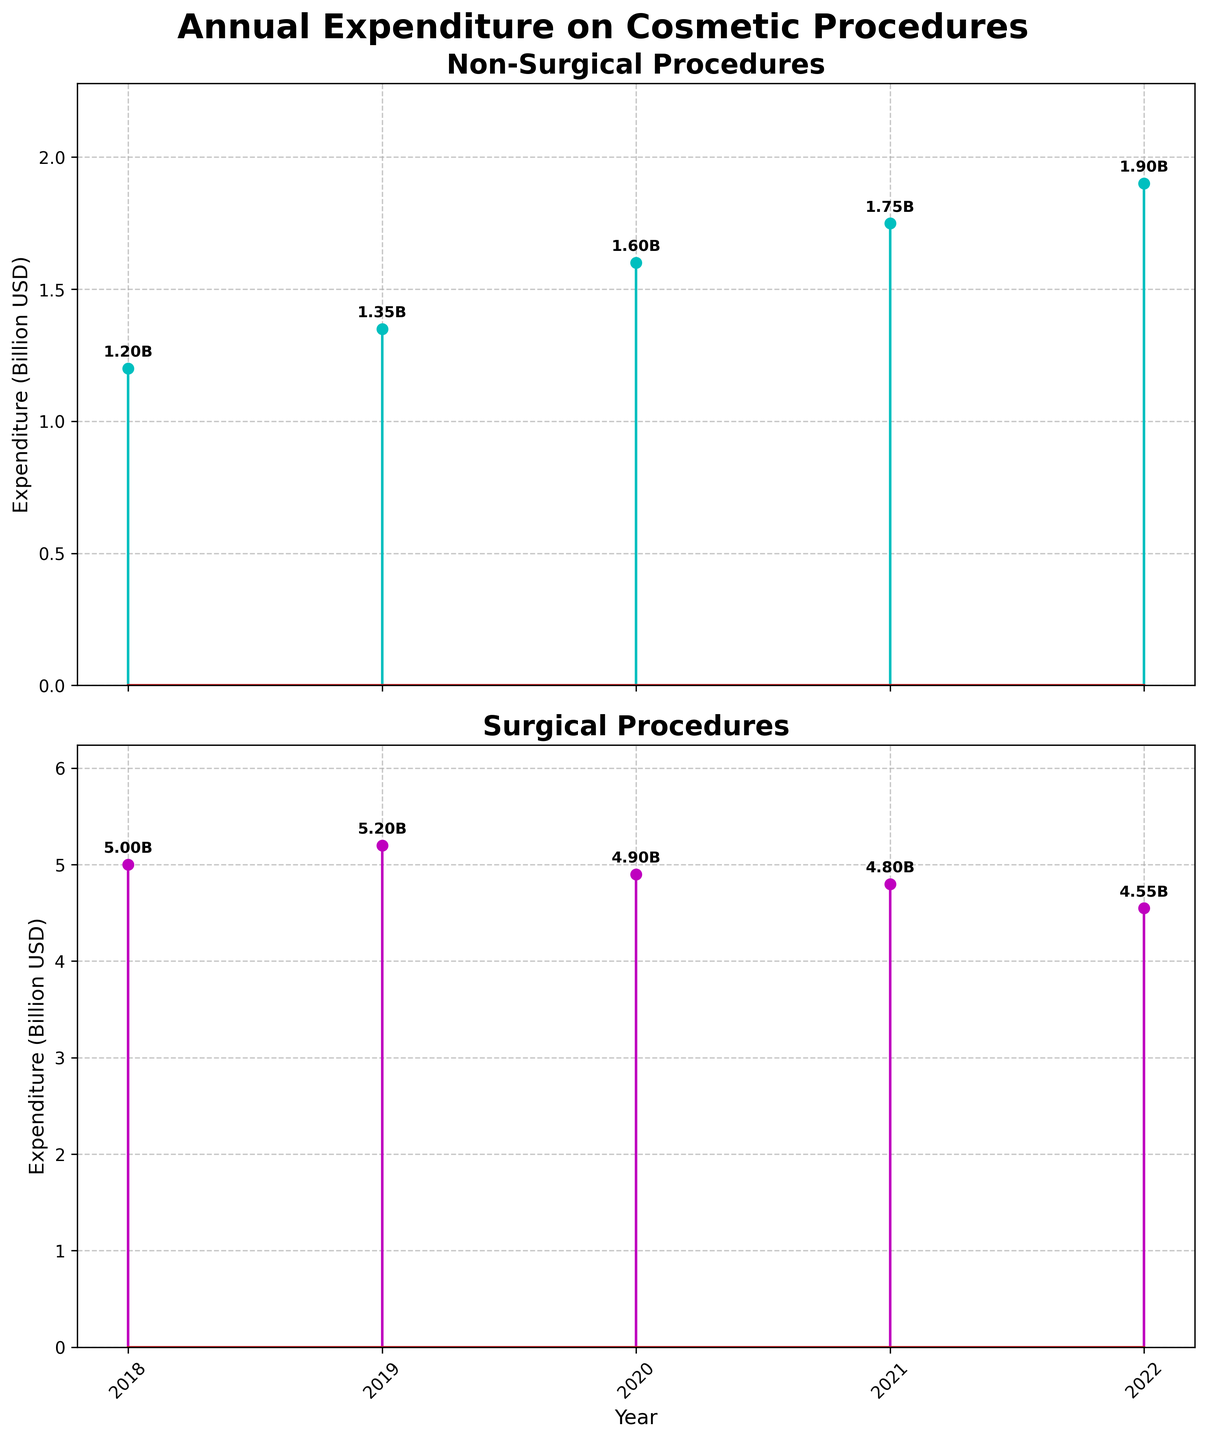What are the titles of the subplots? The titles are located above each subplot. The first subplot is titled "Non-Surgical Procedures" and the second subplot is titled "Surgical Procedures".
Answer: Non-Surgical Procedures, Surgical Procedures What is the total expenditure on Non-Surgical procedures in 2022? The value is labeled directly above the data point at the year 2022 in the Non-Surgical subplot.
Answer: $1.90B Which year had the highest expenditure on Surgical procedures? Look at the highest data point in the Surgical subplot and check the corresponding year marked on the x-axis. The highest data point is in the year 2019.
Answer: 2019 How did the expenditure on Non-Surgical procedures change from 2018 to 2022? Identify the values for the years 2018 and 2022 in the Non-Surgical subplot, then subtract the 2018 value from the 2022 value: 1.90 - 1.20 = 0.7. The expenditure increased by $0.70B.
Answer: Increased by $0.70B How does the expenditure on Non-Surgical procedures in 2022 compare to Surgical procedures in the same year? Locate both values for 2022 in the Non-Surgical and Surgical subplots. Non-Surgical is 1.90B, and Surgical is 4.55B. Compare the two: 1.90 is less than 4.55, so the expenditure on Non-Surgical is lower.
Answer: Non-Surgical is lower What is the average annual expenditure on Non-Surgical procedures over the period 2018-2022? Sum all Non-Surgical expenditures and divide by the number of years: (1.20 + 1.35 + 1.60 + 1.75 + 1.90) / 5 = 7.80 / 5 = 1.56.
Answer: $1.56B In which year did expenditure on Surgical procedures first fall below $5 billion? Check each year chronologically on the Surgical subplot to see the expenditure drop below $5 billion. It first happens in 2020.
Answer: 2020 Is the trend of annual expenditure on Non-Surgical procedures increasing or decreasing from 2018 to 2022? Observe the pattern of the data points in the Non-Surgical subplot from 2018 to 2022. The data points show an increasing trend.
Answer: Increasing By how much did the expenditure on Surgical procedures fall from 2019 to 2022? Find the values for 2019 and 2022 in the Surgical subplot: 5.20 - 4.55 = 0.65. The expenditure fell by $0.65B.
Answer: $0.65B What is the average difference in expenditure between Non-Surgical and Surgical procedures from 2018 to 2022? Calculate the difference for each year, sum them up, and divide by 5. Differences: (3.80, 3.85, 3.30, 3.05, 2.65). Sum: 16.65. Average: 16.65 / 5 = 3.33.
Answer: $3.33B 